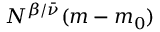Convert formula to latex. <formula><loc_0><loc_0><loc_500><loc_500>N ^ { \beta / { \bar { \nu } } } ( m - m _ { 0 } )</formula> 